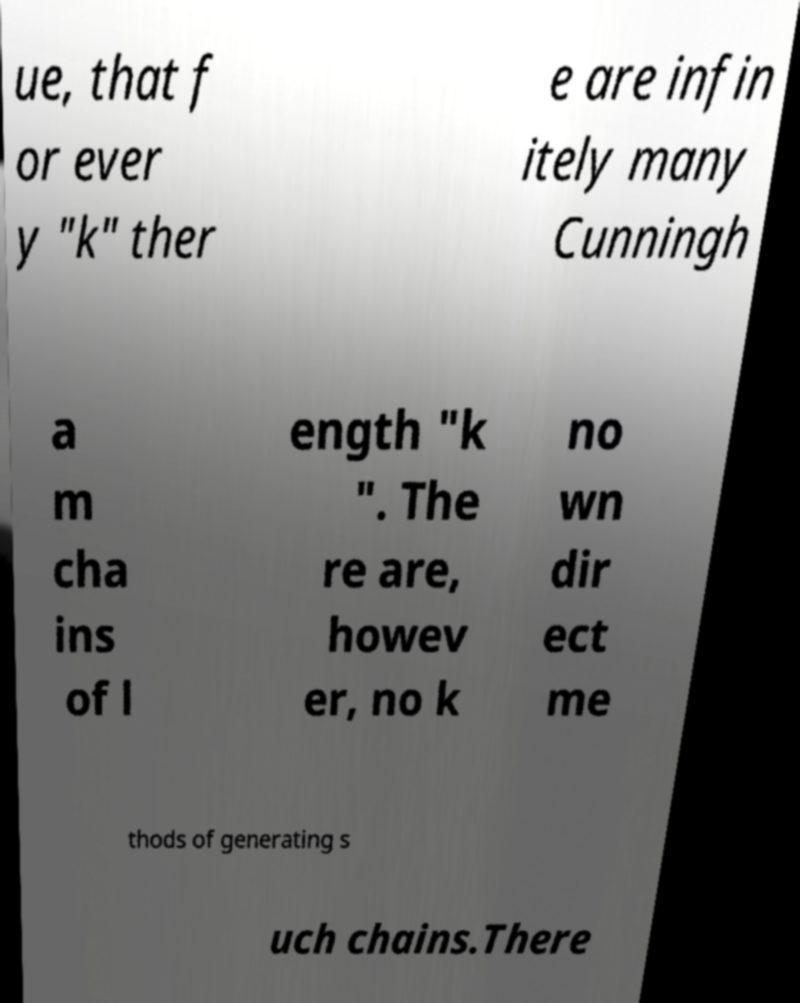Can you accurately transcribe the text from the provided image for me? ue, that f or ever y "k" ther e are infin itely many Cunningh a m cha ins of l ength "k ". The re are, howev er, no k no wn dir ect me thods of generating s uch chains.There 